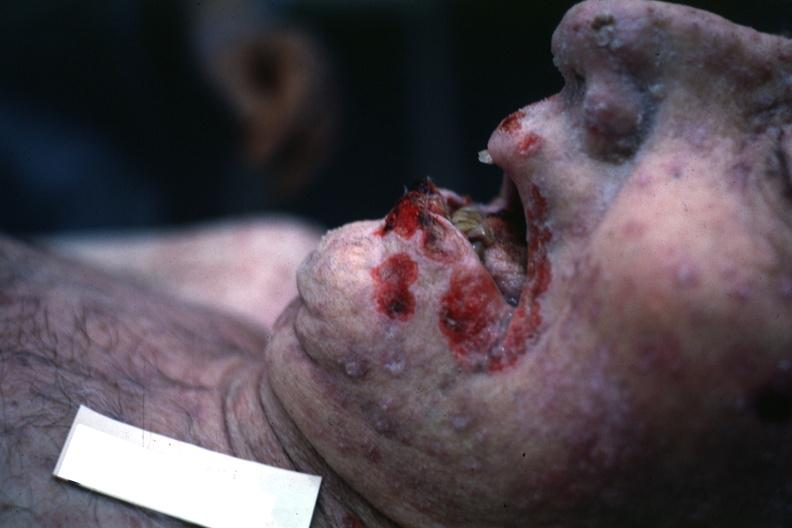where is this?
Answer the question using a single word or phrase. Oral 